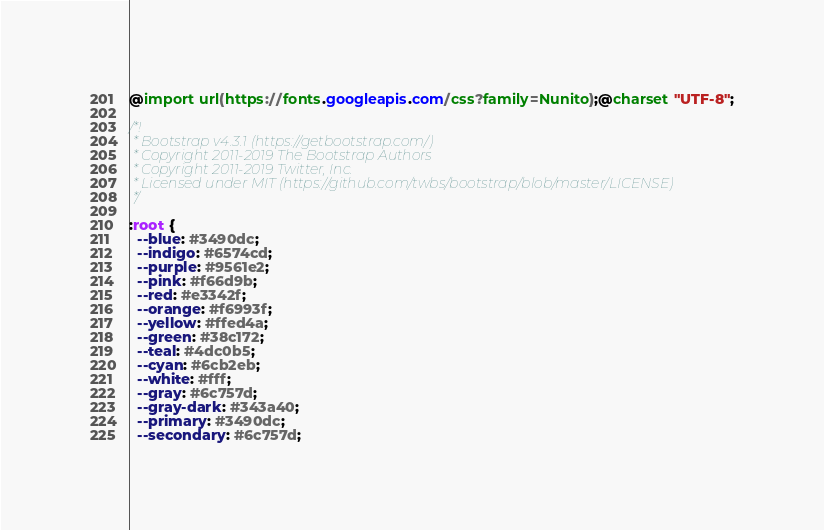<code> <loc_0><loc_0><loc_500><loc_500><_CSS_>@import url(https://fonts.googleapis.com/css?family=Nunito);@charset "UTF-8";

/*!
 * Bootstrap v4.3.1 (https://getbootstrap.com/)
 * Copyright 2011-2019 The Bootstrap Authors
 * Copyright 2011-2019 Twitter, Inc.
 * Licensed under MIT (https://github.com/twbs/bootstrap/blob/master/LICENSE)
 */

:root {
  --blue: #3490dc;
  --indigo: #6574cd;
  --purple: #9561e2;
  --pink: #f66d9b;
  --red: #e3342f;
  --orange: #f6993f;
  --yellow: #ffed4a;
  --green: #38c172;
  --teal: #4dc0b5;
  --cyan: #6cb2eb;
  --white: #fff;
  --gray: #6c757d;
  --gray-dark: #343a40;
  --primary: #3490dc;
  --secondary: #6c757d;</code> 